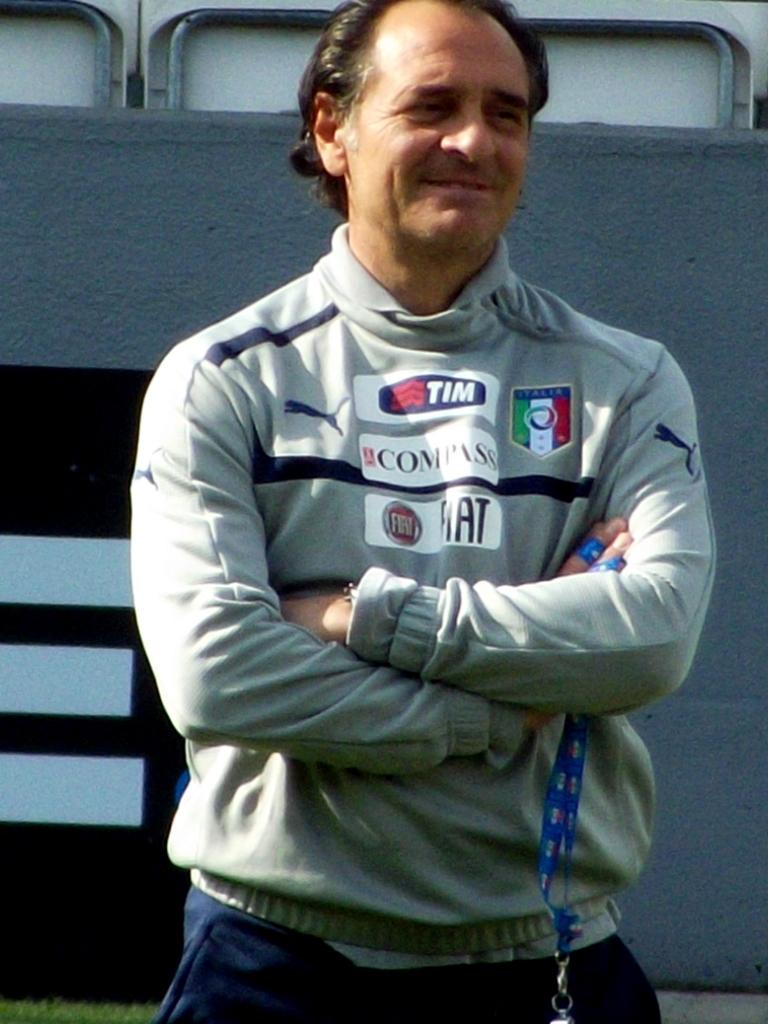<image>
Write a terse but informative summary of the picture. A man has a shirt with several logos on it including COMPASS. 